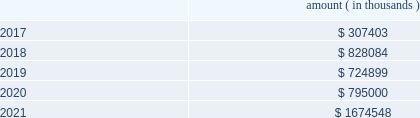Entergy corporation and subsidiaries notes to financial statements ( a ) consists of pollution control revenue bonds and environmental revenue bonds , some of which are secured by collateral first mortgage bonds .
( b ) these notes do not have a stated interest rate , but have an implicit interest rate of 4.8% ( 4.8 % ) .
( c ) pursuant to the nuclear waste policy act of 1982 , entergy 2019s nuclear owner/licensee subsidiaries have contracts with the doe for spent nuclear fuel disposal service .
The contracts include a one-time fee for generation prior to april 7 , 1983 .
Entergy arkansas is the only entergy company that generated electric power with nuclear fuel prior to that date and includes the one-time fee , plus accrued interest , in long-term debt .
( d ) see note 10 to the financial statements for further discussion of the waterford 3 lease obligation and entergy louisiana 2019s acquisition of the equity participant 2019s beneficial interest in the waterford 3 leased assets and for further discussion of the grand gulf lease obligation .
( e ) this note does not have a stated interest rate , but has an implicit interest rate of 7.458% ( 7.458 % ) .
( f ) the fair value excludes lease obligations of $ 57 million at entergy louisiana and $ 34 million at system energy , and long-term doe obligations of $ 182 million at entergy arkansas , and includes debt due within one year .
Fair values are classified as level 2 in the fair value hierarchy discussed in note 15 to the financial statements and are based on prices derived from inputs such as benchmark yields and reported trades .
The annual long-term debt maturities ( excluding lease obligations and long-term doe obligations ) for debt outstanding as of december 31 , 2016 , for the next five years are as follows : amount ( in thousands ) .
In november 2000 , entergy 2019s non-utility nuclear business purchased the fitzpatrick and indian point 3 power plants in a seller-financed transaction .
As part of the purchase agreement with nypa , entergy recorded a liability representing the net present value of the payments entergy would be liable to nypa for each year that the fitzpatrick and indian point 3 power plants would run beyond their respective original nrc license expiration date .
In october 2015 , entergy announced a planned shutdown of fitzpatrick at the end of its fuel cycle .
As a result of the announcement , entergy reduced this liability by $ 26.4 million pursuant to the terms of the purchase agreement .
In august 2016 , entergy entered into a trust transfer agreement with nypa to transfer the decommissioning trust funds and decommissioning liabilities for the indian point 3 and fitzpatrick plants to entergy .
As part of the trust transfer agreement , the original decommissioning agreements were amended , and the entergy subsidiaries 2019 obligation to make additional license extension payments to nypa was eliminated .
In the third quarter 2016 , entergy removed the note payable of $ 35.1 million from the consolidated balance sheet .
Entergy louisiana , entergy mississippi , entergy texas , and system energy have obtained long-term financing authorizations from the ferc that extend through october 2017 .
Entergy arkansas has obtained long-term financing authorization from the apsc that extends through december 2018 .
Entergy new orleans has obtained long-term financing authorization from the city council that extends through june 2018 .
Capital funds agreement pursuant to an agreement with certain creditors , entergy corporation has agreed to supply system energy with sufficient capital to : 2022 maintain system energy 2019s equity capital at a minimum of 35% ( 35 % ) of its total capitalization ( excluding short- term debt ) ; .
How much were liabilities impacted by the impact of the october 2015 planned shutdown of fitzpatrick and the 2016 decommissioning of the indian point 3 and fitzpatrick? 
Computations: (26.4 + 35.1)
Answer: 61.5. 